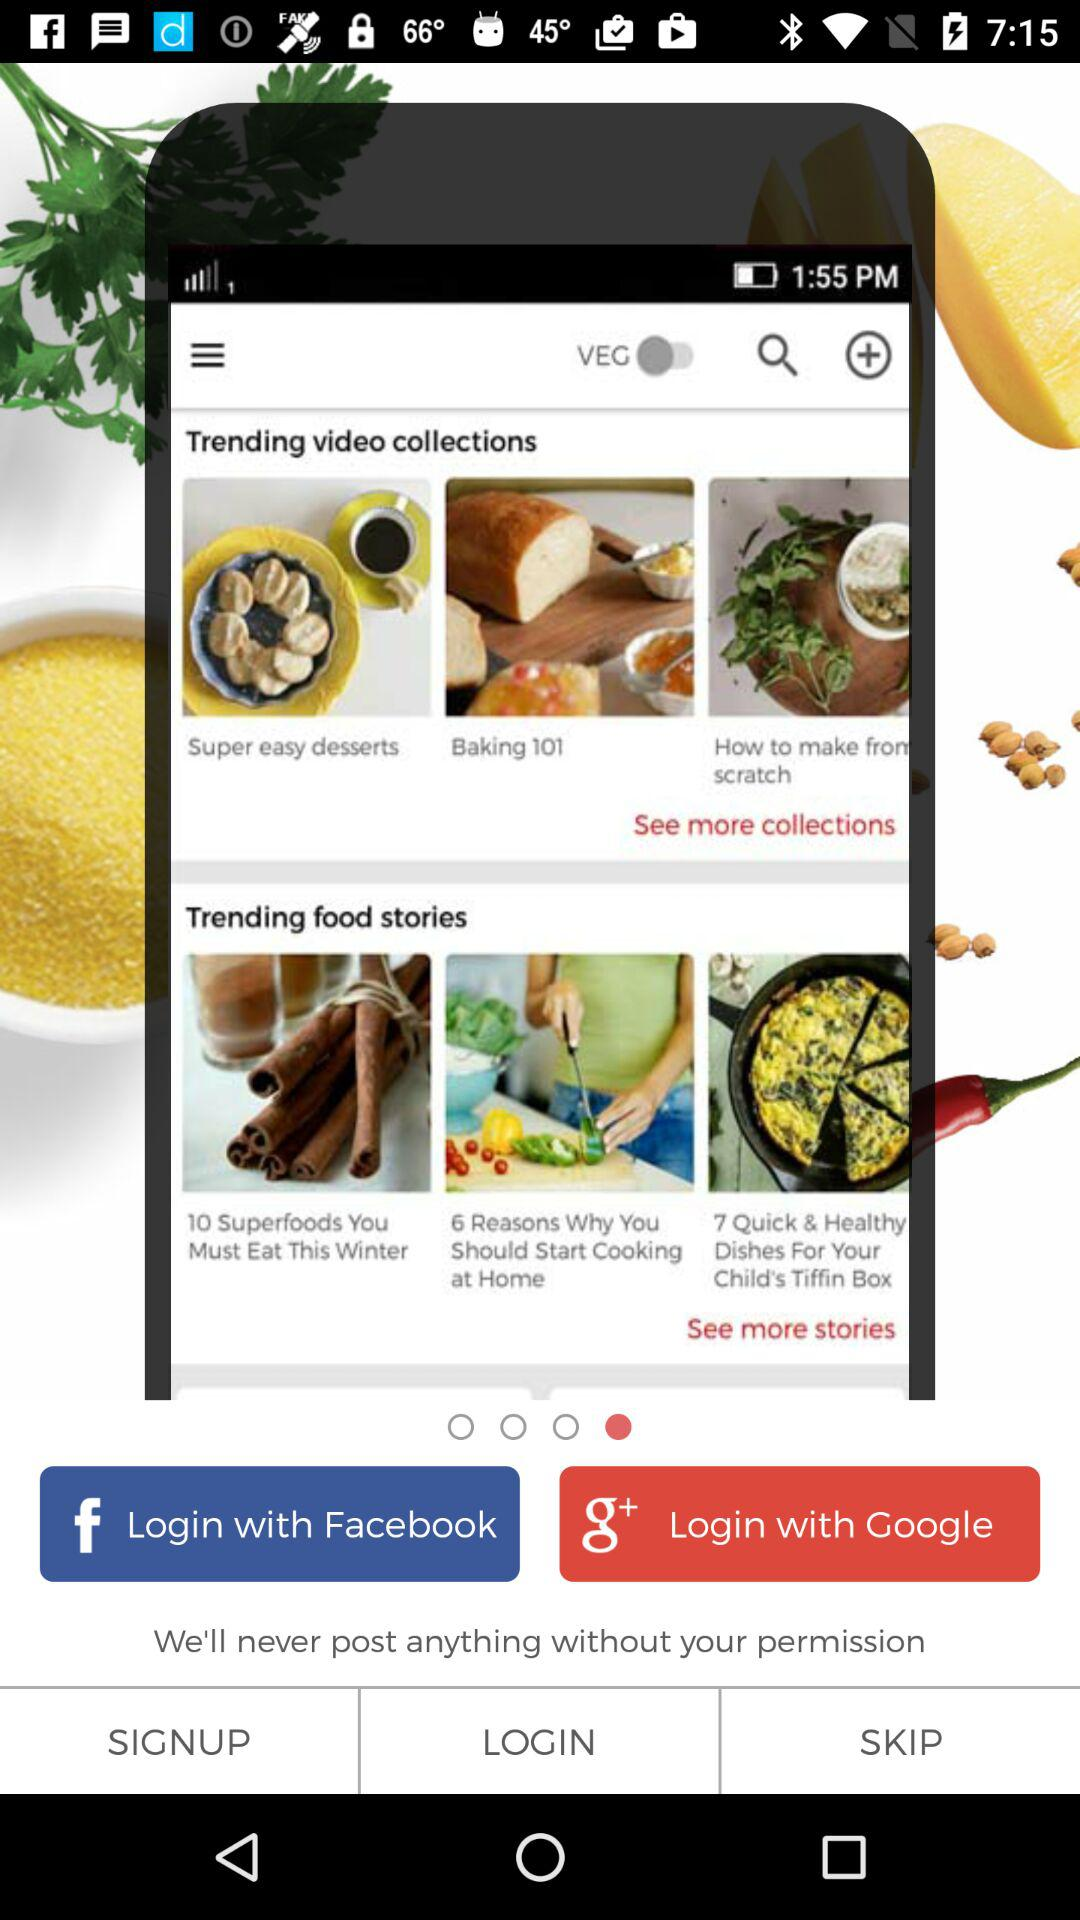Through what applications can a user log in with? The applications are "Facebook" and "Google". 